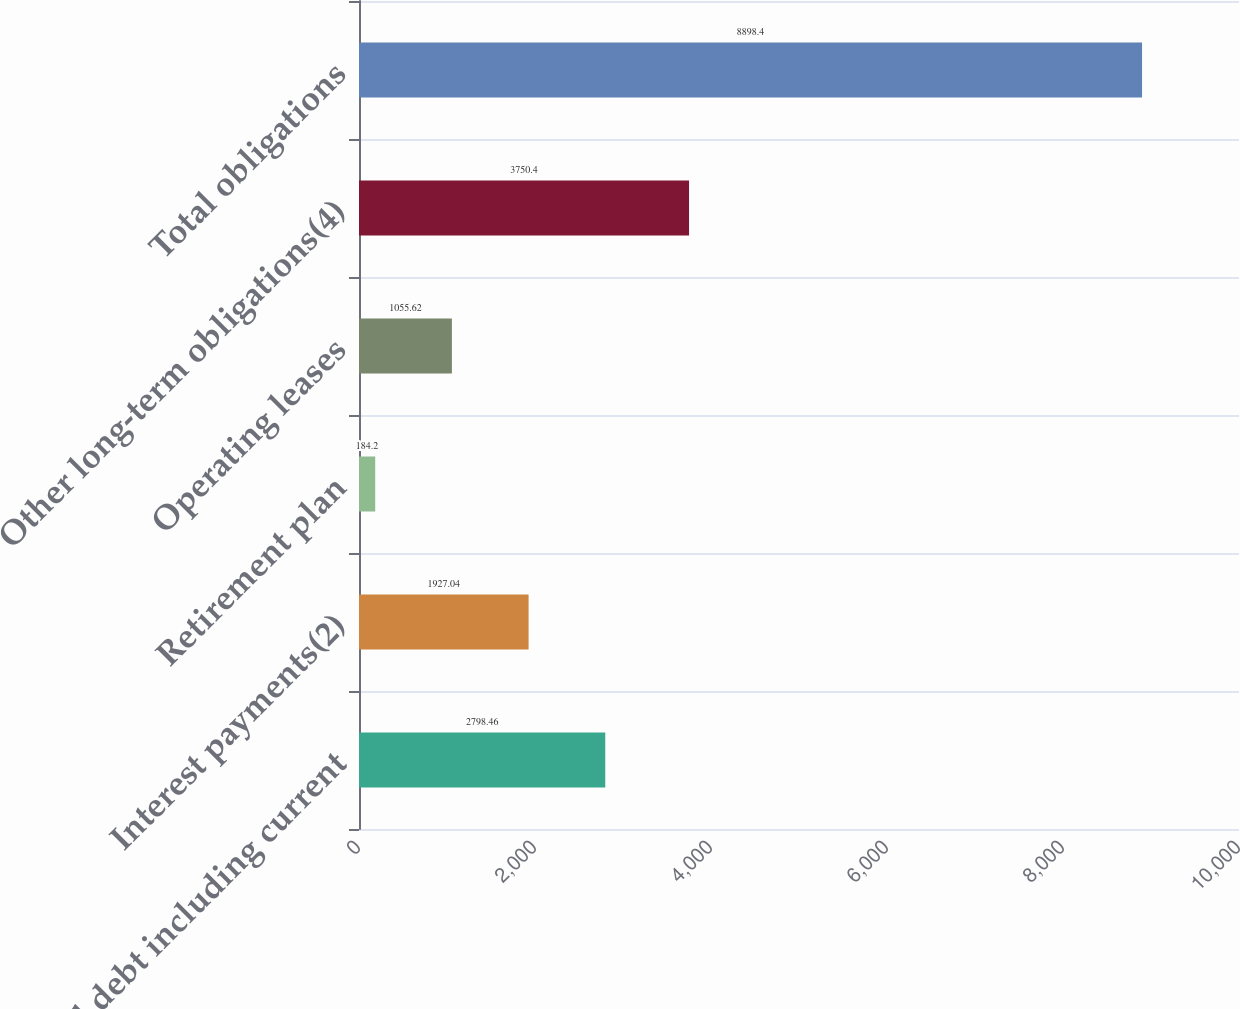Convert chart. <chart><loc_0><loc_0><loc_500><loc_500><bar_chart><fcel>Total debt including current<fcel>Interest payments(2)<fcel>Retirement plan<fcel>Operating leases<fcel>Other long-term obligations(4)<fcel>Total obligations<nl><fcel>2798.46<fcel>1927.04<fcel>184.2<fcel>1055.62<fcel>3750.4<fcel>8898.4<nl></chart> 